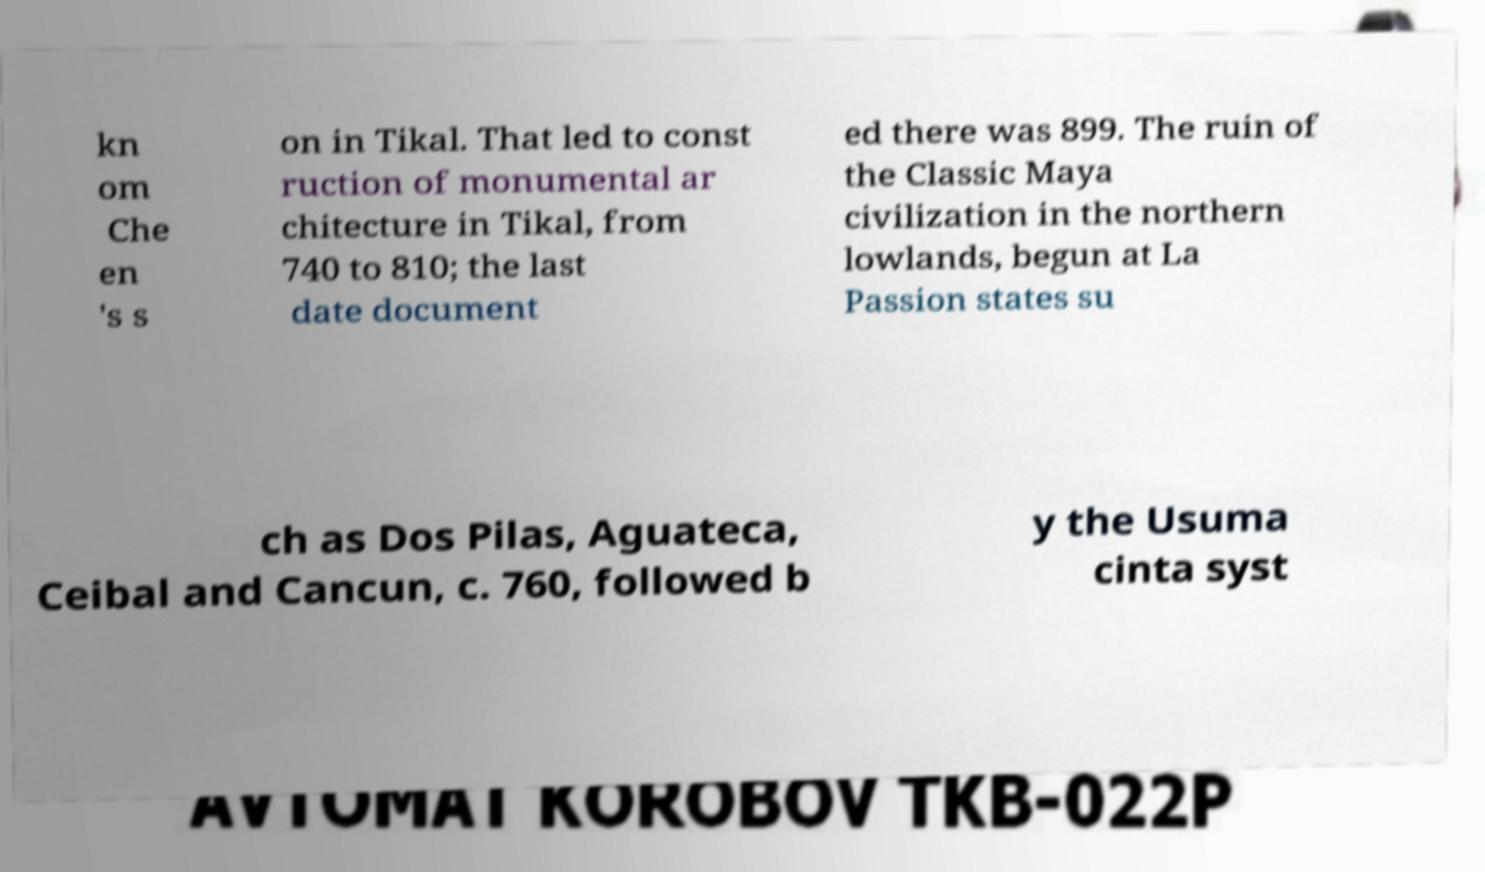Please read and relay the text visible in this image. What does it say? kn om Che en 's s on in Tikal. That led to const ruction of monumental ar chitecture in Tikal, from 740 to 810; the last date document ed there was 899. The ruin of the Classic Maya civilization in the northern lowlands, begun at La Passion states su ch as Dos Pilas, Aguateca, Ceibal and Cancun, c. 760, followed b y the Usuma cinta syst 